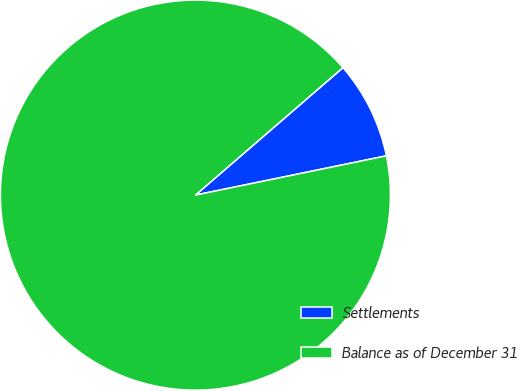Convert chart to OTSL. <chart><loc_0><loc_0><loc_500><loc_500><pie_chart><fcel>Settlements<fcel>Balance as of December 31<nl><fcel>8.11%<fcel>91.89%<nl></chart> 